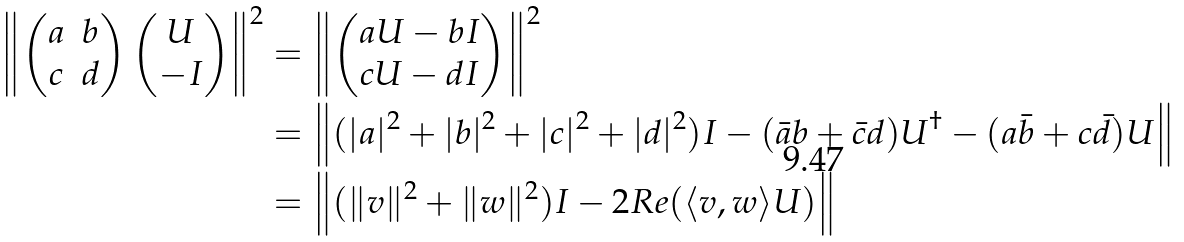<formula> <loc_0><loc_0><loc_500><loc_500>\left \| \begin{pmatrix} a & b \\ c & d \end{pmatrix} \begin{pmatrix} U \\ - I \end{pmatrix} \right \| ^ { 2 } & = \left \| \begin{pmatrix} a U - b I \\ c U - d I \end{pmatrix} \right \| ^ { 2 } \\ & = \left \| ( | a | ^ { 2 } + | b | ^ { 2 } + | c | ^ { 2 } + | d | ^ { 2 } ) I - ( \bar { a } b + \bar { c } d ) U ^ { \dagger } - ( a \bar { b } + c \bar { d } ) U \right \| \\ & = \left \| ( \| v \| ^ { 2 } + \| w \| ^ { 2 } ) I - 2 R e ( \langle v , w \rangle U ) \right \|</formula> 